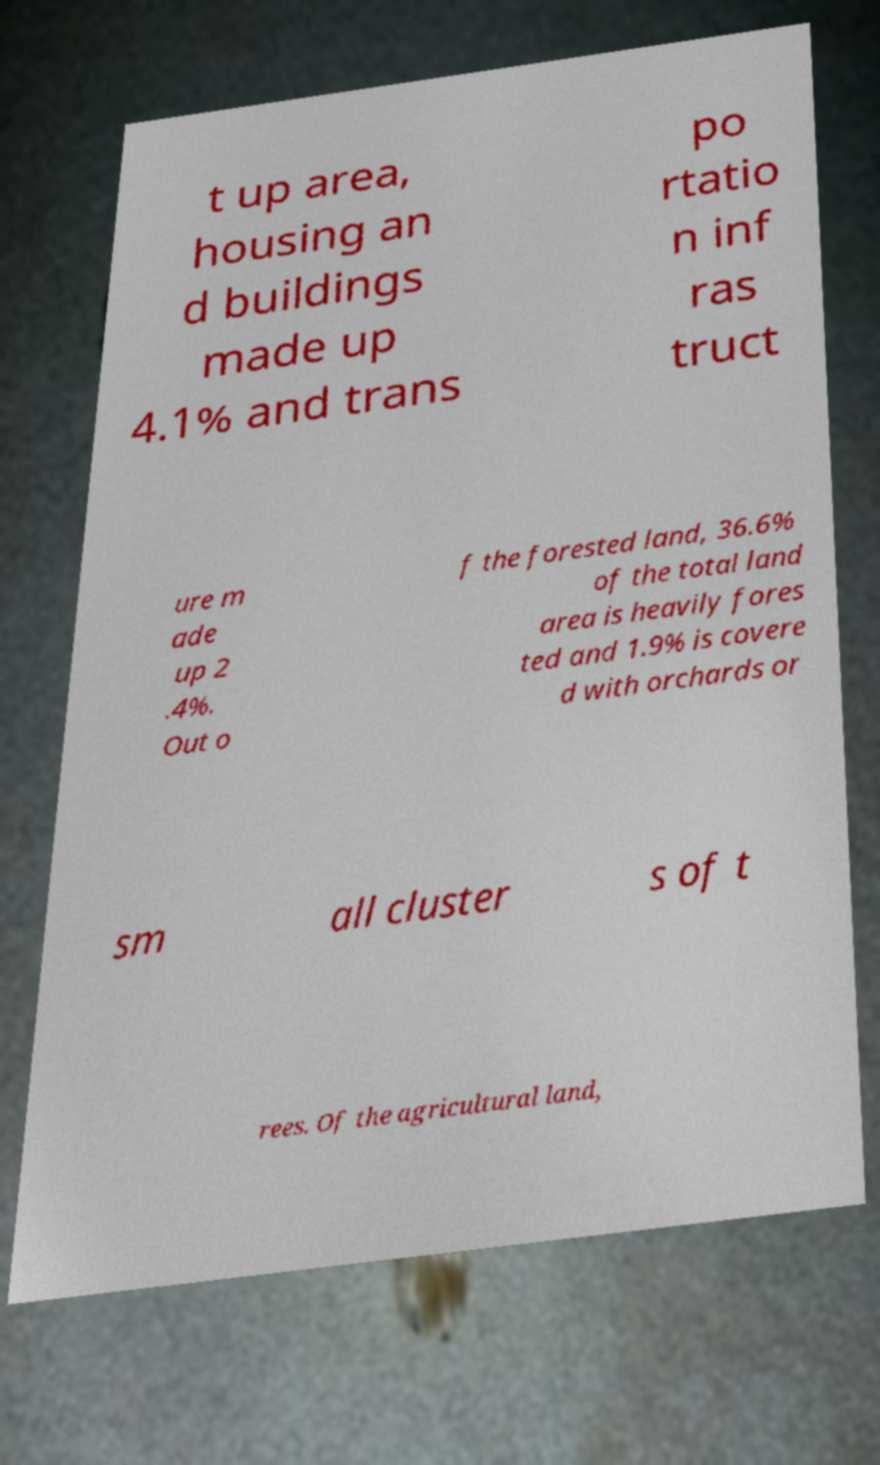There's text embedded in this image that I need extracted. Can you transcribe it verbatim? t up area, housing an d buildings made up 4.1% and trans po rtatio n inf ras truct ure m ade up 2 .4%. Out o f the forested land, 36.6% of the total land area is heavily fores ted and 1.9% is covere d with orchards or sm all cluster s of t rees. Of the agricultural land, 